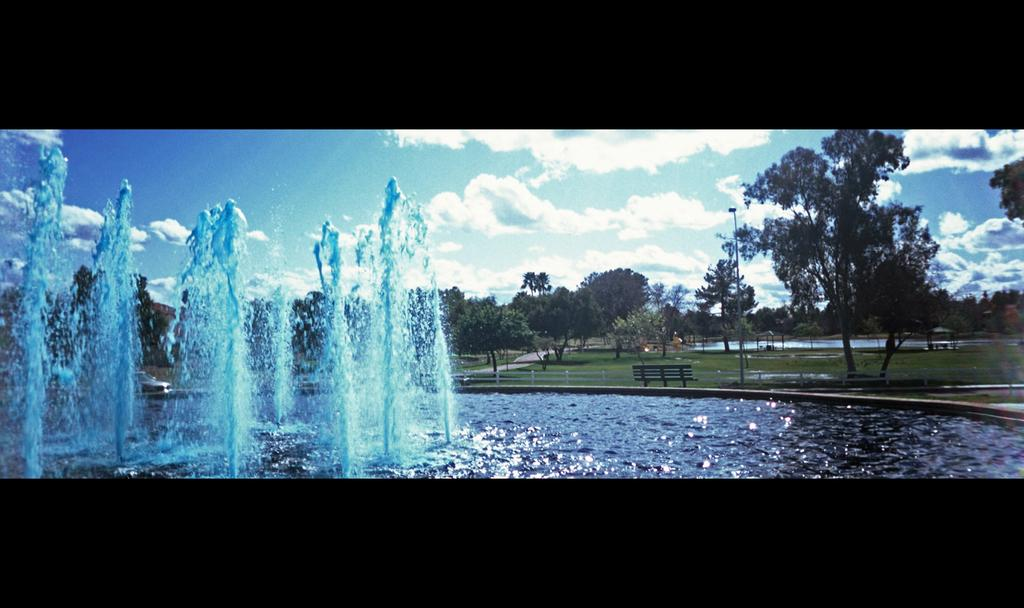What is the main feature in the image? There is a fountain with water in the image. What can be seen in the background of the image? There are trees and the sky visible in the background of the image. Are there any clouds in the sky? Yes, there are clouds in the background of the image. What type of seating is present in the image? There is a bench in the image. What other object can be seen in the image? There is a pole in the image. What type of key is used to unlock the mist in the image? There is no mist or key present in the image. How does the walkway look like in the image? There is no walkway mentioned in the provided facts, so we cannot describe its appearance. 